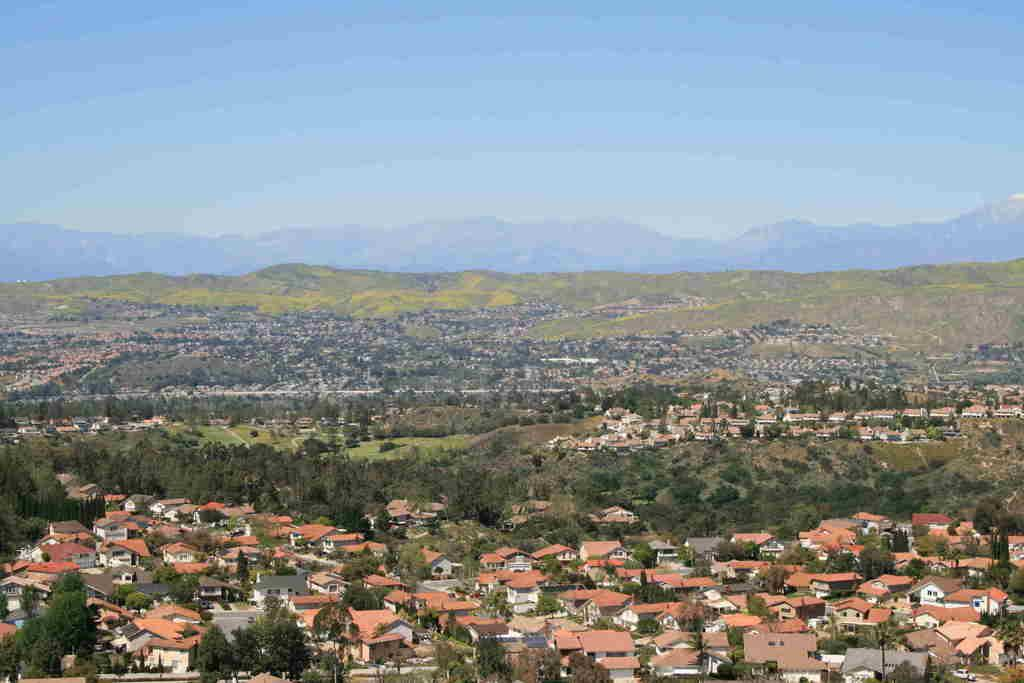What type of structures can be seen in the image? There are many houses in the image. What other natural elements are present in the image? There are trees in the image. How are the houses and trees arranged in the image? The houses and trees are arranged from left to right. What color is the sky in the image? The sky is blue in color. Can you see anyone coughing in the image? There is no indication of anyone coughing in the image. What type of brake is visible on the trees in the image? There are no brakes present in the image; it features houses and trees. 